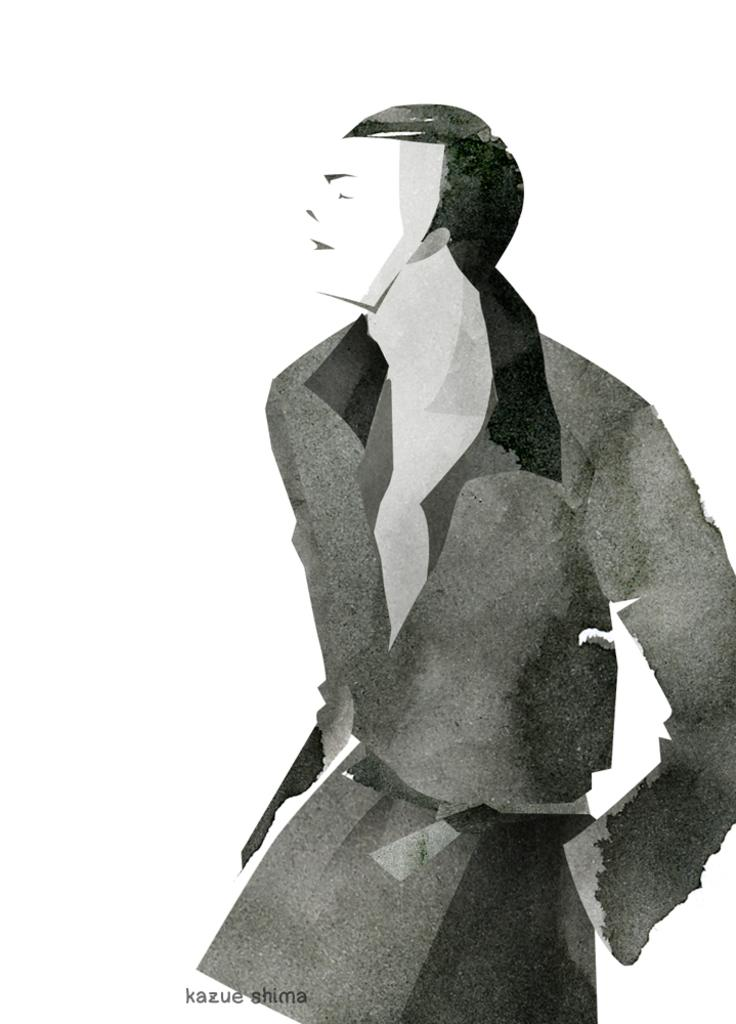What is depicted in the painting in the image? There is a painting of a man in the image. What color is the background of the image? The background of the image is white. What can be found at the bottom of the image? There is text at the bottom of the image. What type of popcorn is being served by the laborer in the image? There is no popcorn or laborer present in the image; it features a painting of a man with a white background and text at the bottom. How many police officers are visible in the image? There are no police officers present in the image. 